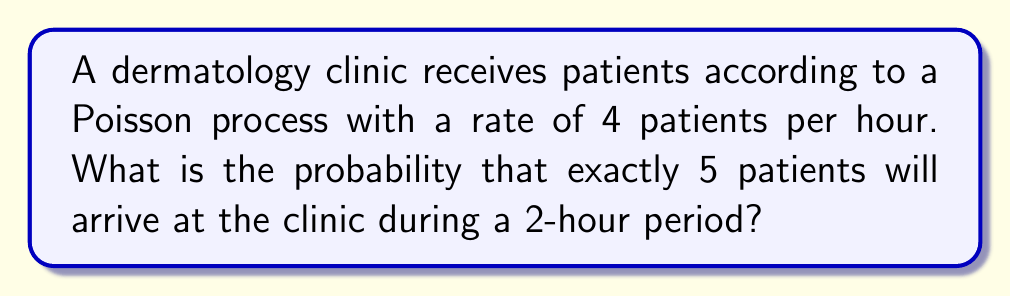Teach me how to tackle this problem. Let's approach this step-by-step:

1) In a Poisson process, the number of events (in this case, patient arrivals) in a fixed interval follows a Poisson distribution.

2) The Poisson distribution is characterized by its rate parameter λ, which is the average number of events per unit time multiplied by the time interval.

3) In this case:
   - Rate = 4 patients per hour
   - Time interval = 2 hours
   - λ = 4 * 2 = 8 patients

4) The probability mass function for a Poisson distribution is:

   $$P(X = k) = \frac{e^{-λ}λ^k}{k!}$$

   Where:
   - e is Euler's number (approximately 2.71828)
   - λ is the rate parameter
   - k is the number of events we're interested in (in this case, 5)

5) Plugging in our values:

   $$P(X = 5) = \frac{e^{-8}8^5}{5!}$$

6) Let's calculate this step-by-step:
   - $e^{-8} ≈ 0.000335$
   - $8^5 = 32768$
   - $5! = 120$

7) Putting it all together:

   $$P(X = 5) = \frac{0.000335 * 32768}{120} ≈ 0.0916$$

8) Therefore, the probability is approximately 0.0916 or 9.16%.
Answer: 0.0916 